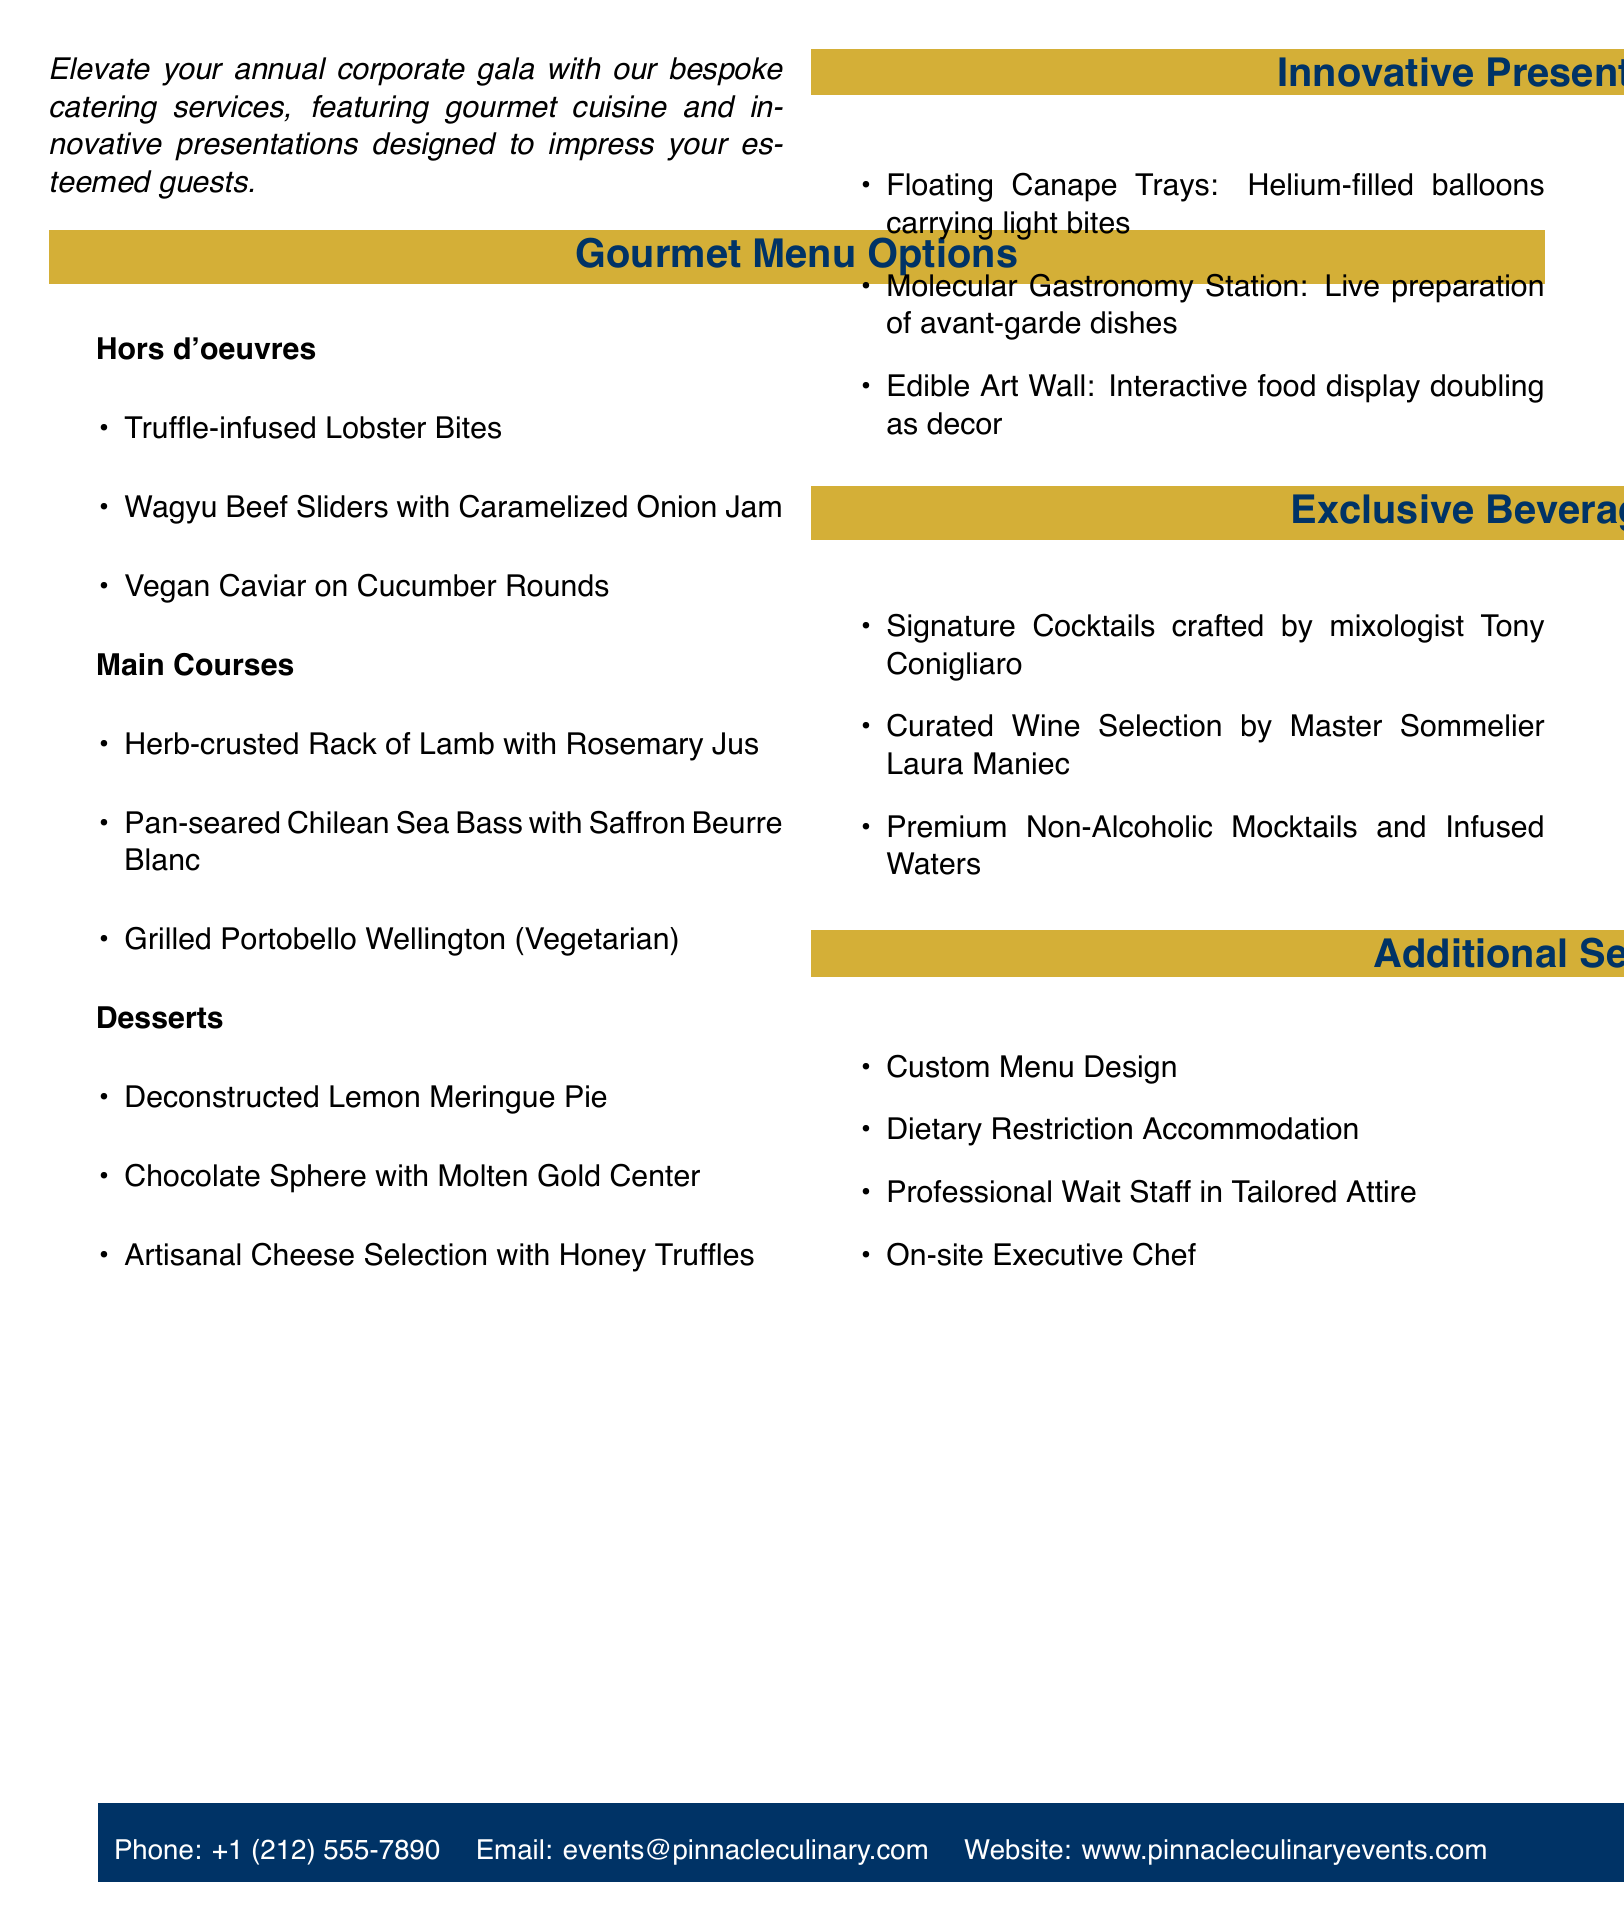What is the title of the catering service? The title prominently displayed at the top of the document is "Exquisite Corporate Gala Catering."
Answer: Exquisite Corporate Gala Catering Who is the catering service provided by? The document mentions "Pinnacle Culinary Events" beneath the title.
Answer: Pinnacle Culinary Events What is one of the hors d'oeuvres offered? There are several options listed, and one of them is "Truffle-infused Lobster Bites."
Answer: Truffle-infused Lobster Bites What is the main course option for vegetarians? The document lists "Grilled Portobello Wellington" as a vegetarian option among the main courses.
Answer: Grilled Portobello Wellington What type of dessert features a molten gold center? The dessert with a molten gold center is referred to as "Chocolate Sphere with Molten Gold Center."
Answer: Chocolate Sphere with Molten Gold Center What innovative presentation idea includes helium-filled balloons? The presentation idea described involving helium-filled balloons is "Floating Canape Trays."
Answer: Floating Canape Trays How many exclusive beverage options are mentioned in the document? The document lists three exclusive beverage options under the relevant section.
Answer: Three Is custom menu design offered as a service? The document explicitly states "Custom Menu Design" is one of the additional services provided.
Answer: Yes Who is a mixologist mentioned for creating signature cocktails? The mixologist mentioned is Tony Conigliaro.
Answer: Tony Conigliaro 